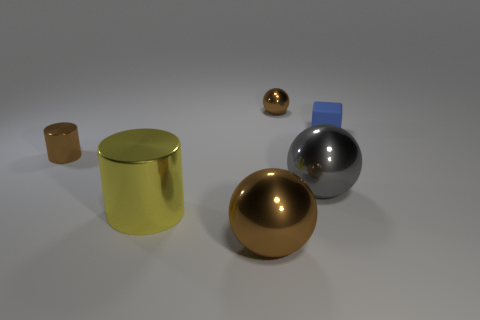Add 3 gray rubber cubes. How many objects exist? 9 Subtract all blocks. How many objects are left? 5 Subtract 0 purple spheres. How many objects are left? 6 Subtract all small red cubes. Subtract all big metal objects. How many objects are left? 3 Add 6 large brown things. How many large brown things are left? 7 Add 4 small cyan rubber cylinders. How many small cyan rubber cylinders exist? 4 